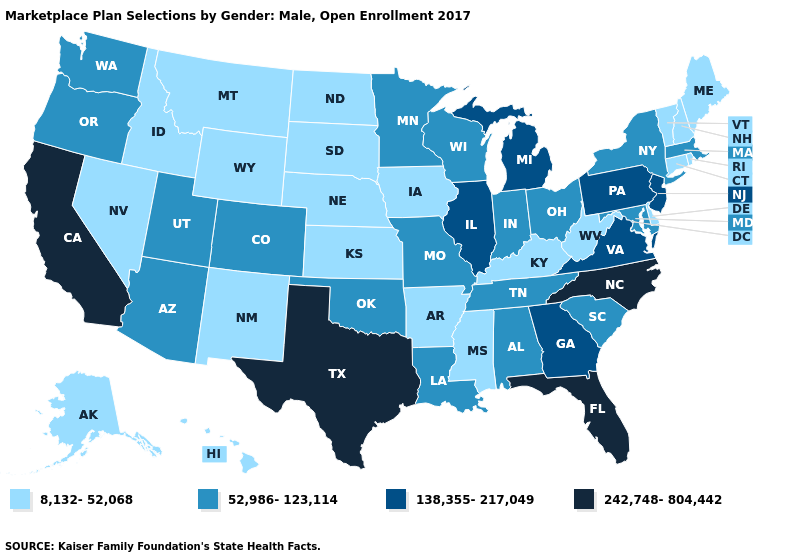Does Missouri have the same value as Idaho?
Concise answer only. No. What is the lowest value in the USA?
Keep it brief. 8,132-52,068. What is the value of Oregon?
Short answer required. 52,986-123,114. How many symbols are there in the legend?
Answer briefly. 4. Does the map have missing data?
Be succinct. No. Name the states that have a value in the range 242,748-804,442?
Give a very brief answer. California, Florida, North Carolina, Texas. Name the states that have a value in the range 52,986-123,114?
Quick response, please. Alabama, Arizona, Colorado, Indiana, Louisiana, Maryland, Massachusetts, Minnesota, Missouri, New York, Ohio, Oklahoma, Oregon, South Carolina, Tennessee, Utah, Washington, Wisconsin. Does Maryland have the same value as Wisconsin?
Answer briefly. Yes. Among the states that border Louisiana , which have the highest value?
Answer briefly. Texas. What is the value of South Dakota?
Keep it brief. 8,132-52,068. Which states have the highest value in the USA?
Be succinct. California, Florida, North Carolina, Texas. What is the highest value in states that border Virginia?
Keep it brief. 242,748-804,442. Among the states that border Wisconsin , which have the lowest value?
Concise answer only. Iowa. Does North Dakota have the same value as Oklahoma?
Be succinct. No. What is the value of Louisiana?
Concise answer only. 52,986-123,114. 